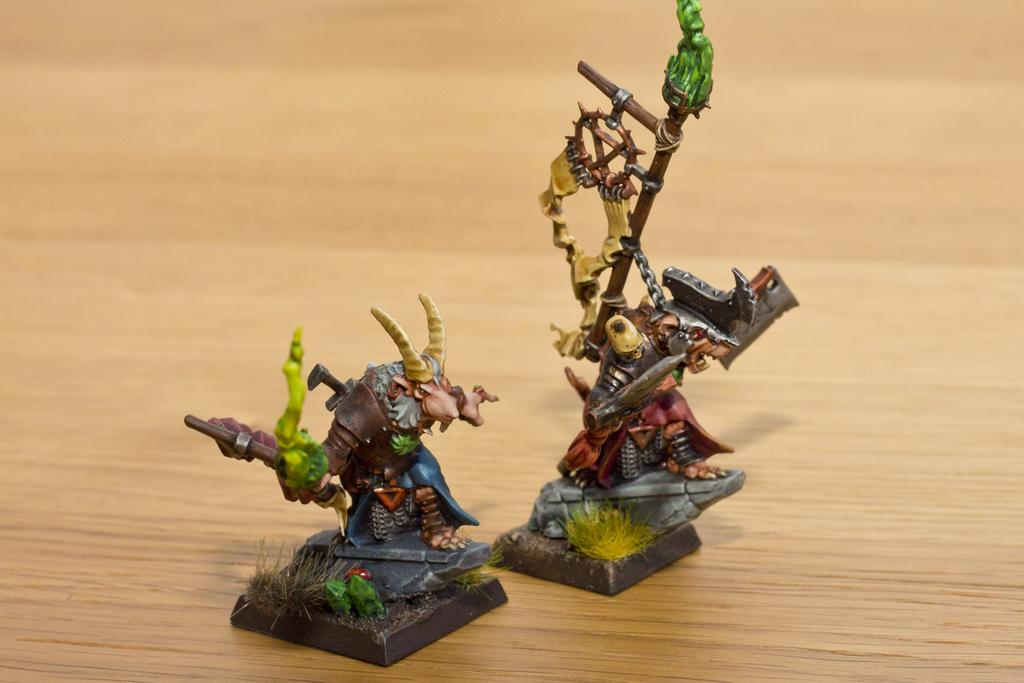How many toys can be seen in the image? There are two toys in the image. What is the color of the surface on which the toys are placed? The toys are placed on a brown surface. What type of store can be seen in the background of the image? There is no store visible in the image; it only shows two toys placed on a brown surface. 